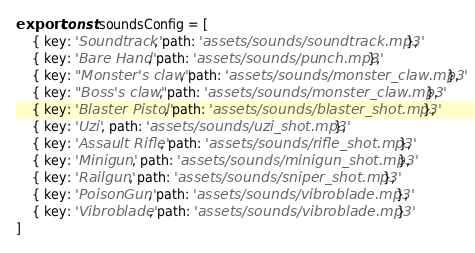Convert code to text. <code><loc_0><loc_0><loc_500><loc_500><_JavaScript_>export const soundsConfig = [
    { key: 'Soundtrack', path: 'assets/sounds/soundtrack.mp3' },
    { key: 'Bare Hand', path: 'assets/sounds/punch.mp3' },
    { key: "Monster's claw", path: 'assets/sounds/monster_claw.mp3' },
    { key: "Boss's claw", path: 'assets/sounds/monster_claw.mp3' },
    { key: 'Blaster Pistol', path: 'assets/sounds/blaster_shot.mp3' },
    { key: 'Uzi', path: 'assets/sounds/uzi_shot.mp3' },
    { key: 'Assault Rifle', path: 'assets/sounds/rifle_shot.mp3' },
    { key: 'Minigun', path: 'assets/sounds/minigun_shot.mp3' },
    { key: 'Railgun', path: 'assets/sounds/sniper_shot.mp3' },
    { key: 'PoisonGun', path: 'assets/sounds/vibroblade.mp3' },
    { key: 'Vibroblade', path: 'assets/sounds/vibroblade.mp3' }
]
</code> 